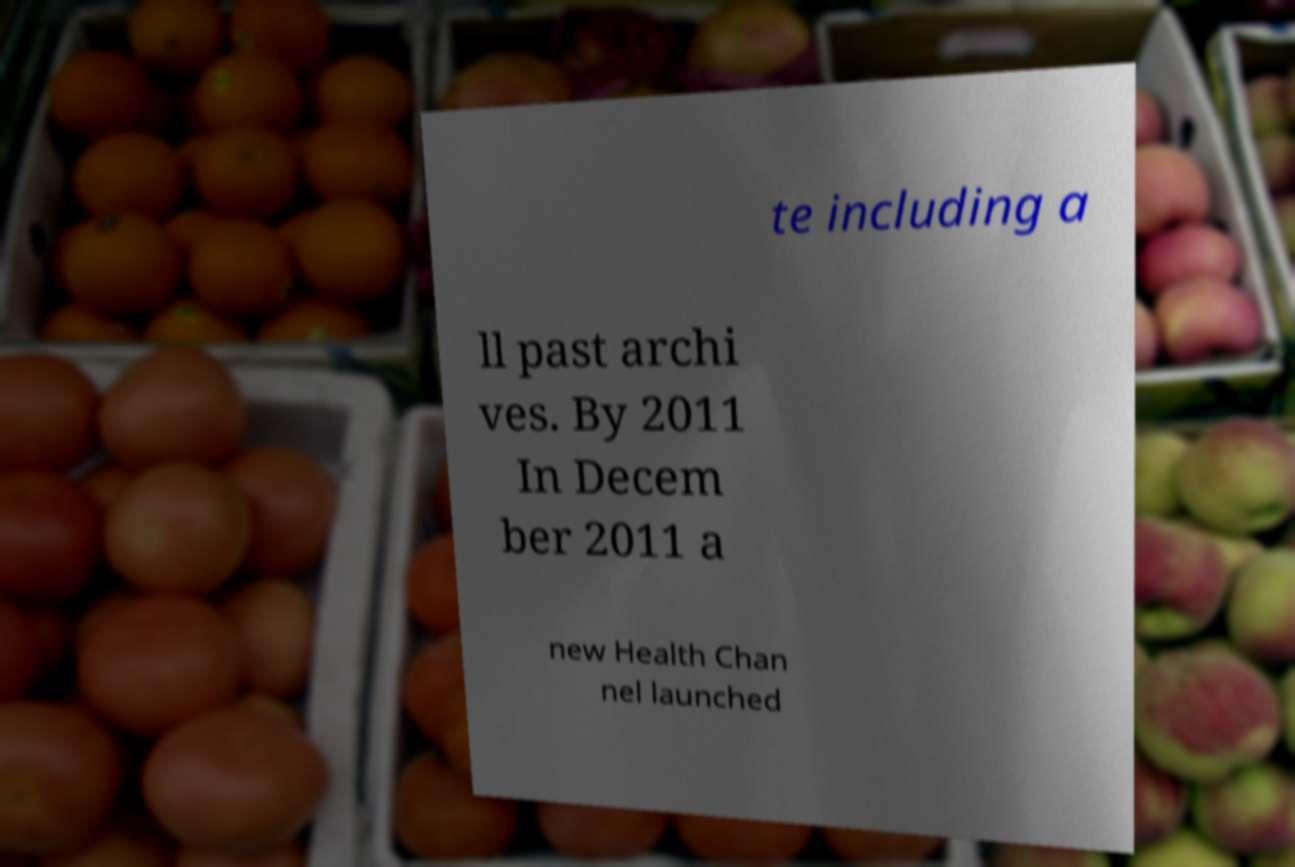Can you accurately transcribe the text from the provided image for me? te including a ll past archi ves. By 2011 In Decem ber 2011 a new Health Chan nel launched 